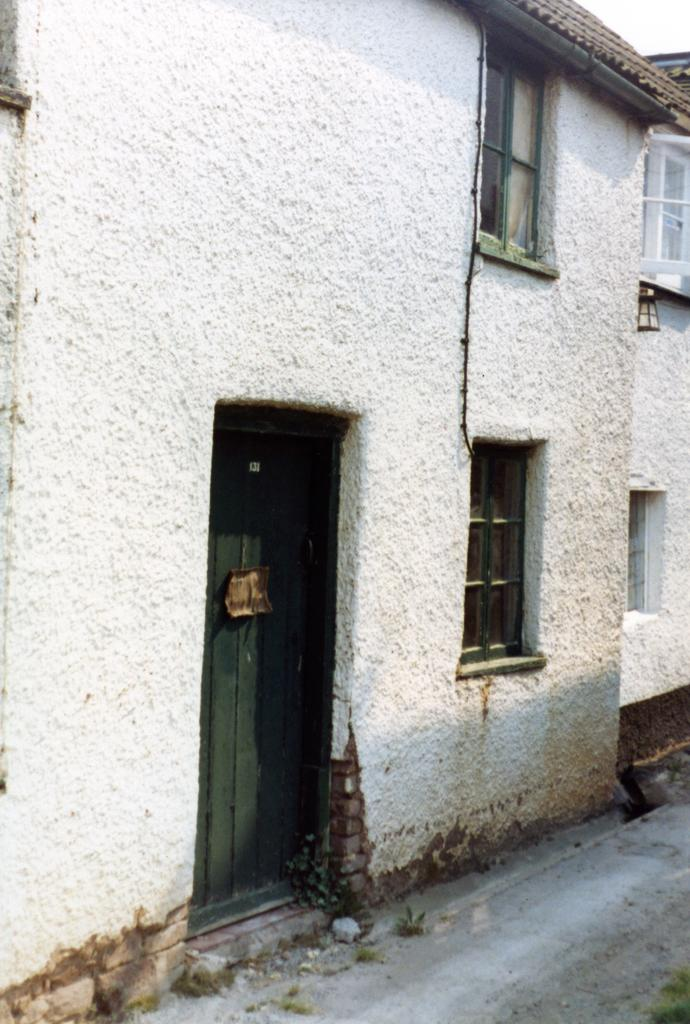What type of structures can be seen in the image? There are houses in the image. What features can be observed on the houses? There are doors and windows visible on the houses. What is visible at the bottom of the image? There is a road visible at the bottom of the image. What type of weather can be seen in the image? The image does not depict any weather conditions; it only shows houses, doors, windows, and a road. What type of grain is visible on the desk in the image? There is no desk present in the image, and therefore no grain can be observed. 